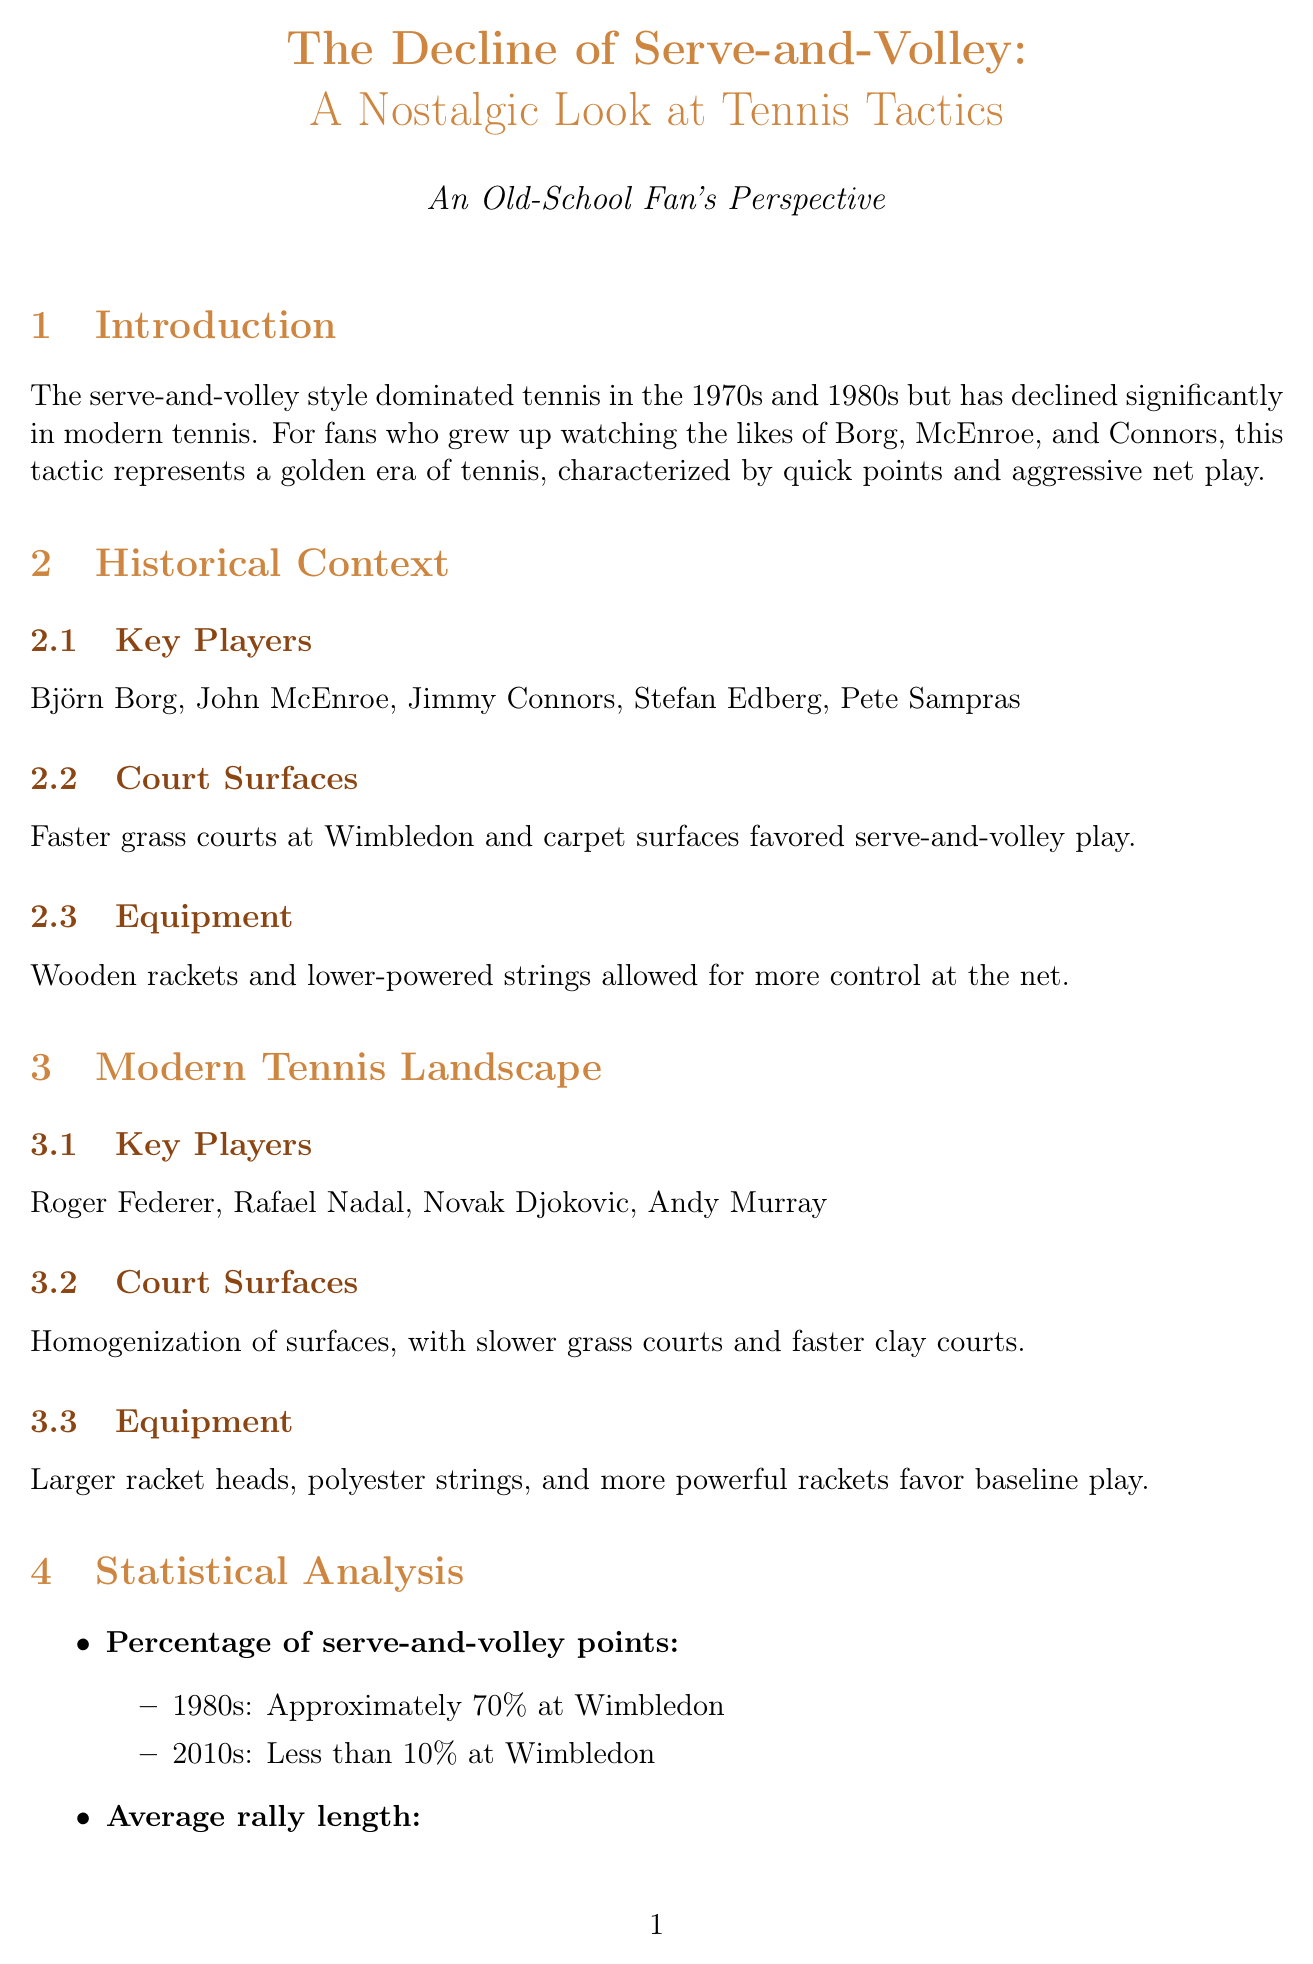what was the percentage of serve-and-volley points in the 1980s? The document states that approximately 70% of serve-and-volley points were recorded at Wimbledon during the 1980s.
Answer: Approximately 70% who are some of the key players from the 1970s and 1980s? The document lists key players from that era as Björn Borg, John McEnroe, Jimmy Connors, Stefan Edberg, and Pete Sampras.
Answer: Björn Borg, John McEnroe, Jimmy Connors, Stefan Edberg, Pete Sampras what has been the success rate of serve-and-volley in the 2010s? According to the document, the success rate of serve-and-volley in the 2010s is around 55%.
Answer: Around 55% how have court surfaces changed from the 1980s to modern tennis? The document notes the homogenization of surfaces, stating that grass courts are slower now, while clay courts are faster compared to the past.
Answer: Slower grass courts and faster clay courts what change in player strategy does the document highlight in modern tennis? The document emphasizes that baseline play has led to longer rallies, indicating a shift in strategy from quick points to extended exchanges.
Answer: Longer rallies who expresses nostalgia for serve-and-volley in the player interviews? John McEnroe expresses nostalgia for the serve-and-volley style in his interview.
Answer: John McEnroe what factors contributed to the decline of serve-and-volley tactics? The document lists several factors including improved return of serve techniques, enhanced physical conditioning, and changes in racket technology.
Answer: Improved return of serve techniques what do older fans feel about the modern game according to the fan perspective section? The document states that many long-time fans miss the excitement and variety of serve-and-volley tennis, feeling that the modern game lacks the same drama.
Answer: They miss the excitement and variety of serve-and-volley tennis 